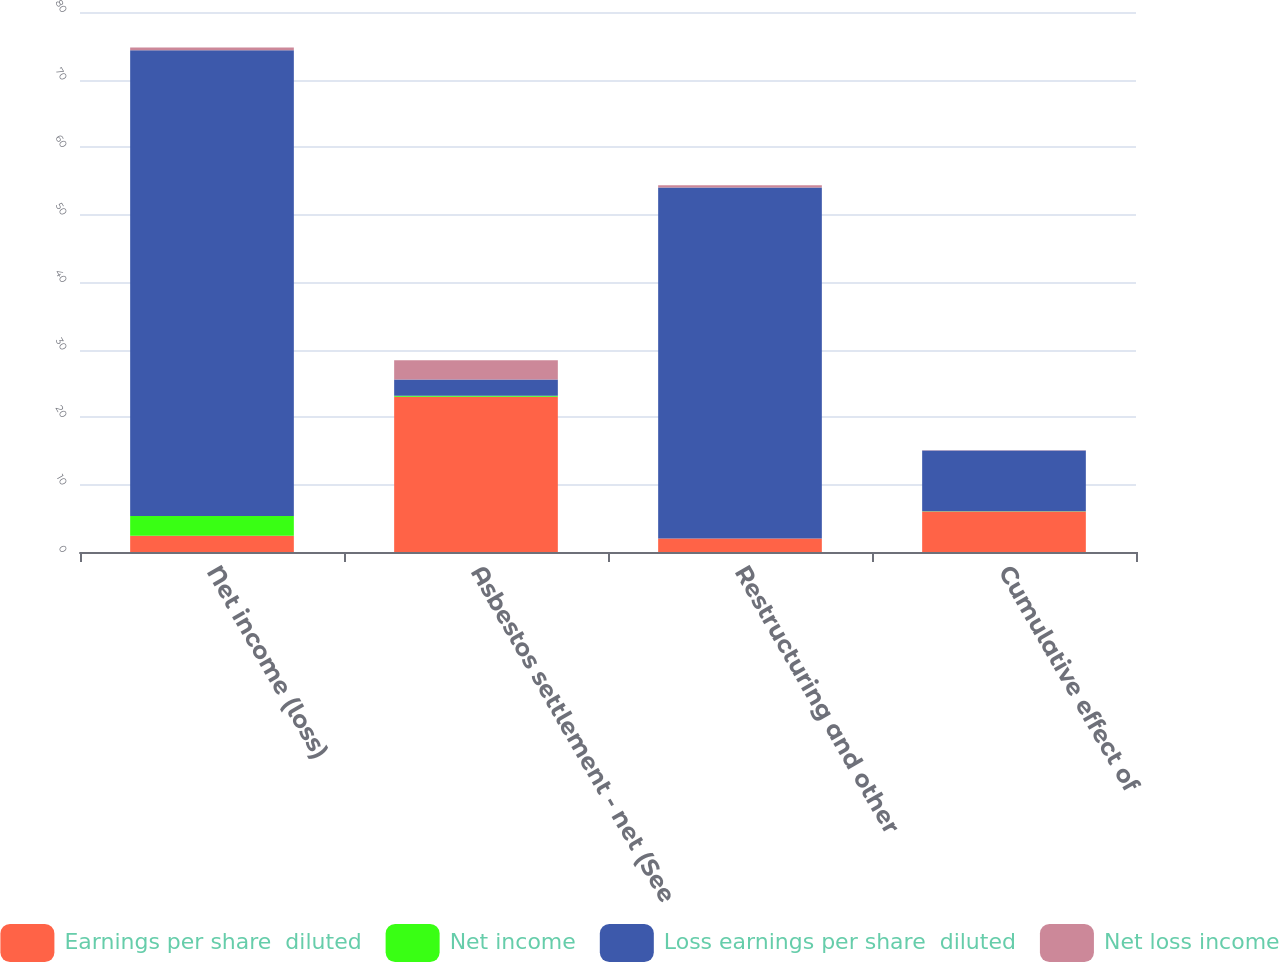Convert chart to OTSL. <chart><loc_0><loc_0><loc_500><loc_500><stacked_bar_chart><ecel><fcel>Net income (loss)<fcel>Asbestos settlement - net (See<fcel>Restructuring and other<fcel>Cumulative effect of<nl><fcel>Earnings per share  diluted<fcel>2.425<fcel>23<fcel>2<fcel>6<nl><fcel>Net income<fcel>2.89<fcel>0.14<fcel>0.01<fcel>0.03<nl><fcel>Loss earnings per share  diluted<fcel>69<fcel>2.425<fcel>52<fcel>9<nl><fcel>Net loss income<fcel>0.41<fcel>2.85<fcel>0.31<fcel>0.05<nl></chart> 